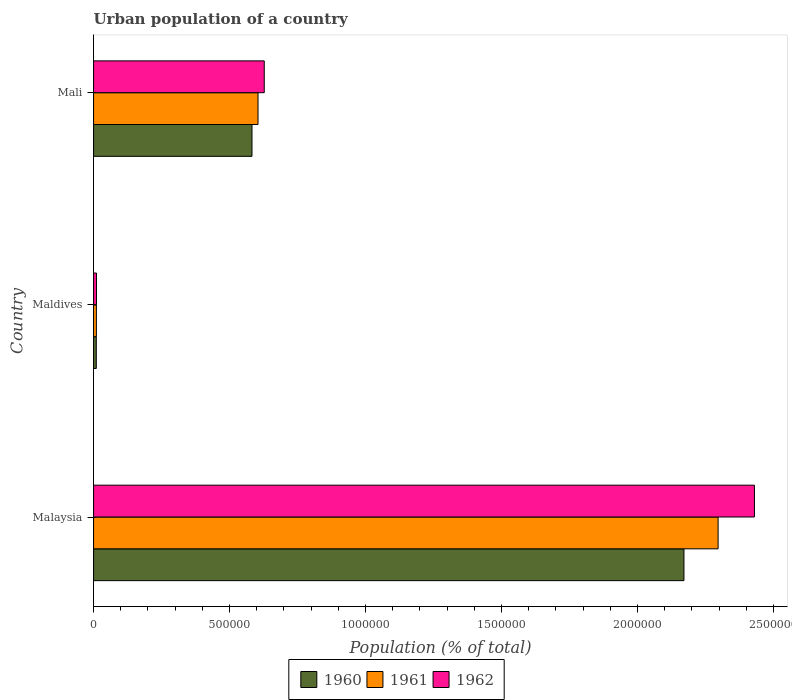Are the number of bars per tick equal to the number of legend labels?
Offer a very short reply. Yes. How many bars are there on the 2nd tick from the bottom?
Ensure brevity in your answer.  3. What is the label of the 3rd group of bars from the top?
Offer a very short reply. Malaysia. In how many cases, is the number of bars for a given country not equal to the number of legend labels?
Offer a very short reply. 0. What is the urban population in 1960 in Maldives?
Your response must be concise. 1.00e+04. Across all countries, what is the maximum urban population in 1962?
Offer a terse response. 2.43e+06. Across all countries, what is the minimum urban population in 1961?
Your response must be concise. 1.04e+04. In which country was the urban population in 1961 maximum?
Your response must be concise. Malaysia. In which country was the urban population in 1960 minimum?
Provide a succinct answer. Maldives. What is the total urban population in 1962 in the graph?
Offer a very short reply. 3.07e+06. What is the difference between the urban population in 1962 in Maldives and that in Mali?
Offer a terse response. -6.17e+05. What is the difference between the urban population in 1960 in Malaysia and the urban population in 1962 in Mali?
Provide a succinct answer. 1.54e+06. What is the average urban population in 1960 per country?
Offer a terse response. 9.21e+05. What is the difference between the urban population in 1960 and urban population in 1961 in Mali?
Your answer should be compact. -2.22e+04. In how many countries, is the urban population in 1960 greater than 2200000 %?
Give a very brief answer. 0. What is the ratio of the urban population in 1962 in Malaysia to that in Mali?
Give a very brief answer. 3.87. Is the difference between the urban population in 1960 in Malaysia and Mali greater than the difference between the urban population in 1961 in Malaysia and Mali?
Keep it short and to the point. No. What is the difference between the highest and the second highest urban population in 1962?
Offer a very short reply. 1.80e+06. What is the difference between the highest and the lowest urban population in 1961?
Ensure brevity in your answer.  2.29e+06. In how many countries, is the urban population in 1961 greater than the average urban population in 1961 taken over all countries?
Give a very brief answer. 1. Is the sum of the urban population in 1962 in Malaysia and Mali greater than the maximum urban population in 1960 across all countries?
Give a very brief answer. Yes. What does the 1st bar from the top in Malaysia represents?
Ensure brevity in your answer.  1962. How many bars are there?
Provide a succinct answer. 9. Are all the bars in the graph horizontal?
Offer a terse response. Yes. What is the difference between two consecutive major ticks on the X-axis?
Provide a short and direct response. 5.00e+05. Are the values on the major ticks of X-axis written in scientific E-notation?
Ensure brevity in your answer.  No. Does the graph contain any zero values?
Provide a succinct answer. No. Does the graph contain grids?
Offer a terse response. No. How are the legend labels stacked?
Keep it short and to the point. Horizontal. What is the title of the graph?
Your answer should be very brief. Urban population of a country. Does "1991" appear as one of the legend labels in the graph?
Your response must be concise. No. What is the label or title of the X-axis?
Your answer should be compact. Population (% of total). What is the label or title of the Y-axis?
Ensure brevity in your answer.  Country. What is the Population (% of total) of 1960 in Malaysia?
Offer a very short reply. 2.17e+06. What is the Population (% of total) of 1961 in Malaysia?
Provide a succinct answer. 2.30e+06. What is the Population (% of total) of 1962 in Malaysia?
Offer a very short reply. 2.43e+06. What is the Population (% of total) in 1960 in Maldives?
Offer a very short reply. 1.00e+04. What is the Population (% of total) in 1961 in Maldives?
Offer a terse response. 1.04e+04. What is the Population (% of total) of 1962 in Maldives?
Give a very brief answer. 1.07e+04. What is the Population (% of total) in 1960 in Mali?
Provide a succinct answer. 5.82e+05. What is the Population (% of total) of 1961 in Mali?
Make the answer very short. 6.05e+05. What is the Population (% of total) of 1962 in Mali?
Offer a very short reply. 6.28e+05. Across all countries, what is the maximum Population (% of total) of 1960?
Provide a short and direct response. 2.17e+06. Across all countries, what is the maximum Population (% of total) of 1961?
Offer a very short reply. 2.30e+06. Across all countries, what is the maximum Population (% of total) of 1962?
Ensure brevity in your answer.  2.43e+06. Across all countries, what is the minimum Population (% of total) of 1960?
Offer a terse response. 1.00e+04. Across all countries, what is the minimum Population (% of total) in 1961?
Give a very brief answer. 1.04e+04. Across all countries, what is the minimum Population (% of total) of 1962?
Offer a terse response. 1.07e+04. What is the total Population (% of total) of 1960 in the graph?
Offer a very short reply. 2.76e+06. What is the total Population (% of total) in 1961 in the graph?
Offer a terse response. 2.91e+06. What is the total Population (% of total) of 1962 in the graph?
Keep it short and to the point. 3.07e+06. What is the difference between the Population (% of total) in 1960 in Malaysia and that in Maldives?
Your answer should be very brief. 2.16e+06. What is the difference between the Population (% of total) in 1961 in Malaysia and that in Maldives?
Offer a very short reply. 2.29e+06. What is the difference between the Population (% of total) of 1962 in Malaysia and that in Maldives?
Offer a very short reply. 2.42e+06. What is the difference between the Population (% of total) in 1960 in Malaysia and that in Mali?
Provide a short and direct response. 1.59e+06. What is the difference between the Population (% of total) in 1961 in Malaysia and that in Mali?
Provide a short and direct response. 1.69e+06. What is the difference between the Population (% of total) of 1962 in Malaysia and that in Mali?
Provide a short and direct response. 1.80e+06. What is the difference between the Population (% of total) of 1960 in Maldives and that in Mali?
Your answer should be very brief. -5.72e+05. What is the difference between the Population (% of total) of 1961 in Maldives and that in Mali?
Your answer should be very brief. -5.94e+05. What is the difference between the Population (% of total) in 1962 in Maldives and that in Mali?
Offer a very short reply. -6.17e+05. What is the difference between the Population (% of total) of 1960 in Malaysia and the Population (% of total) of 1961 in Maldives?
Provide a short and direct response. 2.16e+06. What is the difference between the Population (% of total) of 1960 in Malaysia and the Population (% of total) of 1962 in Maldives?
Make the answer very short. 2.16e+06. What is the difference between the Population (% of total) in 1961 in Malaysia and the Population (% of total) in 1962 in Maldives?
Keep it short and to the point. 2.29e+06. What is the difference between the Population (% of total) in 1960 in Malaysia and the Population (% of total) in 1961 in Mali?
Make the answer very short. 1.57e+06. What is the difference between the Population (% of total) in 1960 in Malaysia and the Population (% of total) in 1962 in Mali?
Your answer should be very brief. 1.54e+06. What is the difference between the Population (% of total) in 1961 in Malaysia and the Population (% of total) in 1962 in Mali?
Offer a very short reply. 1.67e+06. What is the difference between the Population (% of total) in 1960 in Maldives and the Population (% of total) in 1961 in Mali?
Ensure brevity in your answer.  -5.95e+05. What is the difference between the Population (% of total) of 1960 in Maldives and the Population (% of total) of 1962 in Mali?
Make the answer very short. -6.18e+05. What is the difference between the Population (% of total) of 1961 in Maldives and the Population (% of total) of 1962 in Mali?
Your response must be concise. -6.17e+05. What is the average Population (% of total) in 1960 per country?
Provide a short and direct response. 9.21e+05. What is the average Population (% of total) of 1961 per country?
Your answer should be compact. 9.70e+05. What is the average Population (% of total) of 1962 per country?
Offer a terse response. 1.02e+06. What is the difference between the Population (% of total) of 1960 and Population (% of total) of 1961 in Malaysia?
Ensure brevity in your answer.  -1.26e+05. What is the difference between the Population (% of total) of 1960 and Population (% of total) of 1962 in Malaysia?
Make the answer very short. -2.59e+05. What is the difference between the Population (% of total) of 1961 and Population (% of total) of 1962 in Malaysia?
Provide a short and direct response. -1.34e+05. What is the difference between the Population (% of total) of 1960 and Population (% of total) of 1961 in Maldives?
Keep it short and to the point. -326. What is the difference between the Population (% of total) of 1960 and Population (% of total) of 1962 in Maldives?
Keep it short and to the point. -671. What is the difference between the Population (% of total) in 1961 and Population (% of total) in 1962 in Maldives?
Your response must be concise. -345. What is the difference between the Population (% of total) of 1960 and Population (% of total) of 1961 in Mali?
Your answer should be compact. -2.22e+04. What is the difference between the Population (% of total) of 1960 and Population (% of total) of 1962 in Mali?
Offer a terse response. -4.51e+04. What is the difference between the Population (% of total) of 1961 and Population (% of total) of 1962 in Mali?
Give a very brief answer. -2.29e+04. What is the ratio of the Population (% of total) in 1960 in Malaysia to that in Maldives?
Your response must be concise. 216.16. What is the ratio of the Population (% of total) in 1961 in Malaysia to that in Maldives?
Keep it short and to the point. 221.47. What is the ratio of the Population (% of total) in 1962 in Malaysia to that in Maldives?
Keep it short and to the point. 226.81. What is the ratio of the Population (% of total) of 1960 in Malaysia to that in Mali?
Make the answer very short. 3.73. What is the ratio of the Population (% of total) in 1961 in Malaysia to that in Mali?
Provide a short and direct response. 3.8. What is the ratio of the Population (% of total) in 1962 in Malaysia to that in Mali?
Keep it short and to the point. 3.87. What is the ratio of the Population (% of total) of 1960 in Maldives to that in Mali?
Offer a terse response. 0.02. What is the ratio of the Population (% of total) in 1961 in Maldives to that in Mali?
Provide a succinct answer. 0.02. What is the ratio of the Population (% of total) of 1962 in Maldives to that in Mali?
Provide a short and direct response. 0.02. What is the difference between the highest and the second highest Population (% of total) of 1960?
Provide a short and direct response. 1.59e+06. What is the difference between the highest and the second highest Population (% of total) of 1961?
Keep it short and to the point. 1.69e+06. What is the difference between the highest and the second highest Population (% of total) of 1962?
Your answer should be compact. 1.80e+06. What is the difference between the highest and the lowest Population (% of total) of 1960?
Offer a terse response. 2.16e+06. What is the difference between the highest and the lowest Population (% of total) in 1961?
Offer a very short reply. 2.29e+06. What is the difference between the highest and the lowest Population (% of total) of 1962?
Your answer should be very brief. 2.42e+06. 